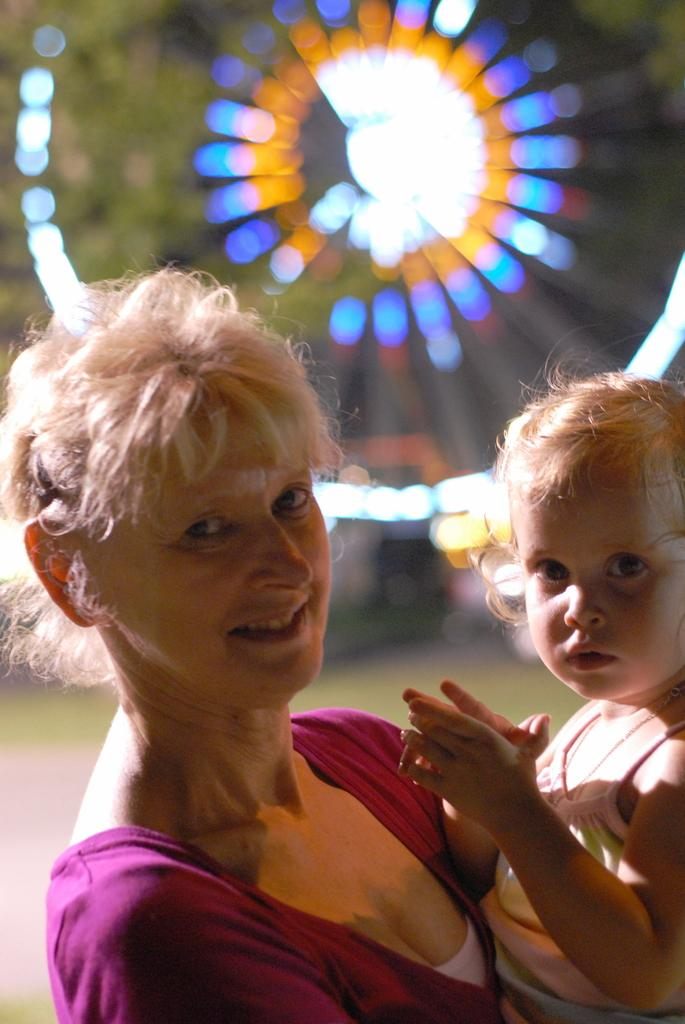Who is the main subject in the image? There is a woman in the image. What is the woman doing in the image? The woman is holding a baby. What can be seen in the background of the image? There is a fun ride and trees in the background of the image. What type of pan is the woman using to cook in the image? There is no pan present in the image; the woman is holding a baby. 